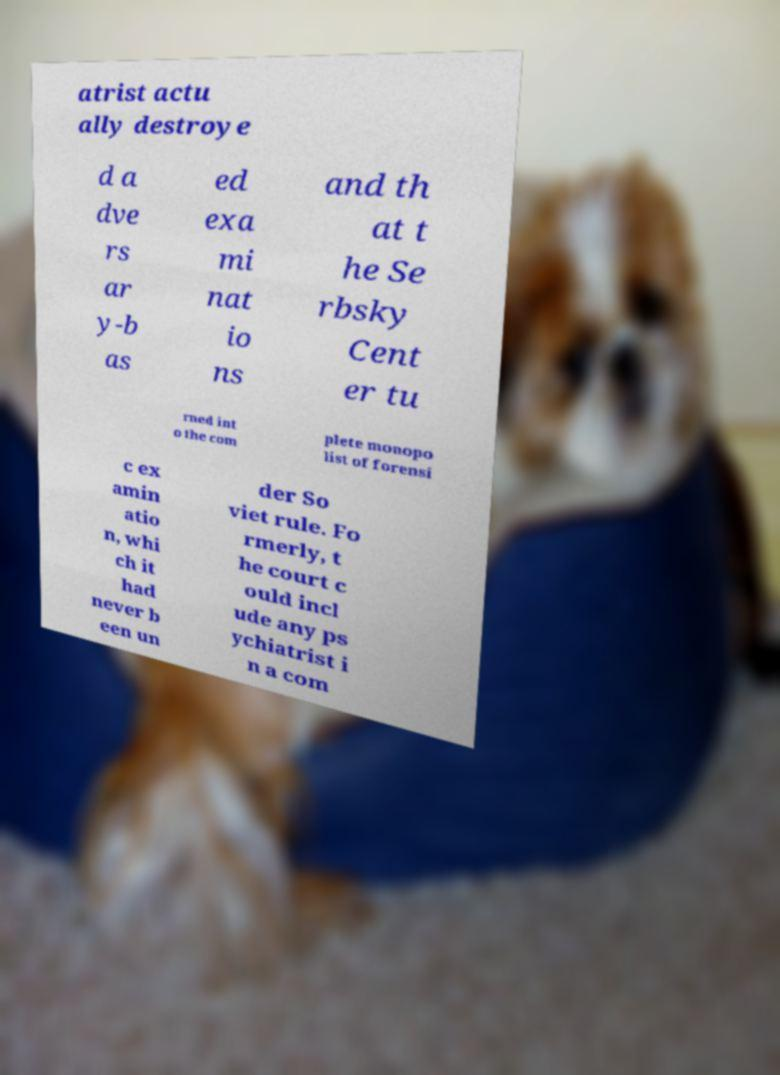Please identify and transcribe the text found in this image. atrist actu ally destroye d a dve rs ar y-b as ed exa mi nat io ns and th at t he Se rbsky Cent er tu rned int o the com plete monopo list of forensi c ex amin atio n, whi ch it had never b een un der So viet rule. Fo rmerly, t he court c ould incl ude any ps ychiatrist i n a com 